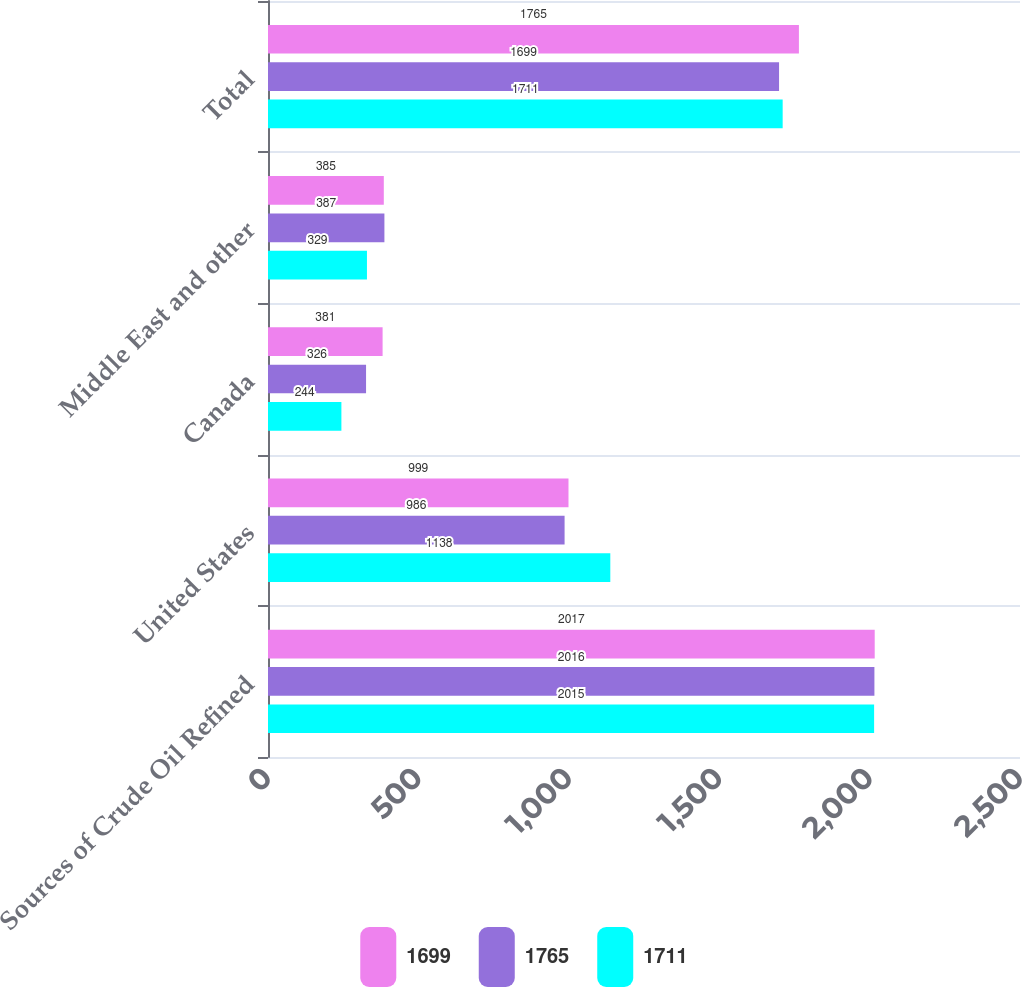Convert chart. <chart><loc_0><loc_0><loc_500><loc_500><stacked_bar_chart><ecel><fcel>Sources of Crude Oil Refined<fcel>United States<fcel>Canada<fcel>Middle East and other<fcel>Total<nl><fcel>1699<fcel>2017<fcel>999<fcel>381<fcel>385<fcel>1765<nl><fcel>1765<fcel>2016<fcel>986<fcel>326<fcel>387<fcel>1699<nl><fcel>1711<fcel>2015<fcel>1138<fcel>244<fcel>329<fcel>1711<nl></chart> 